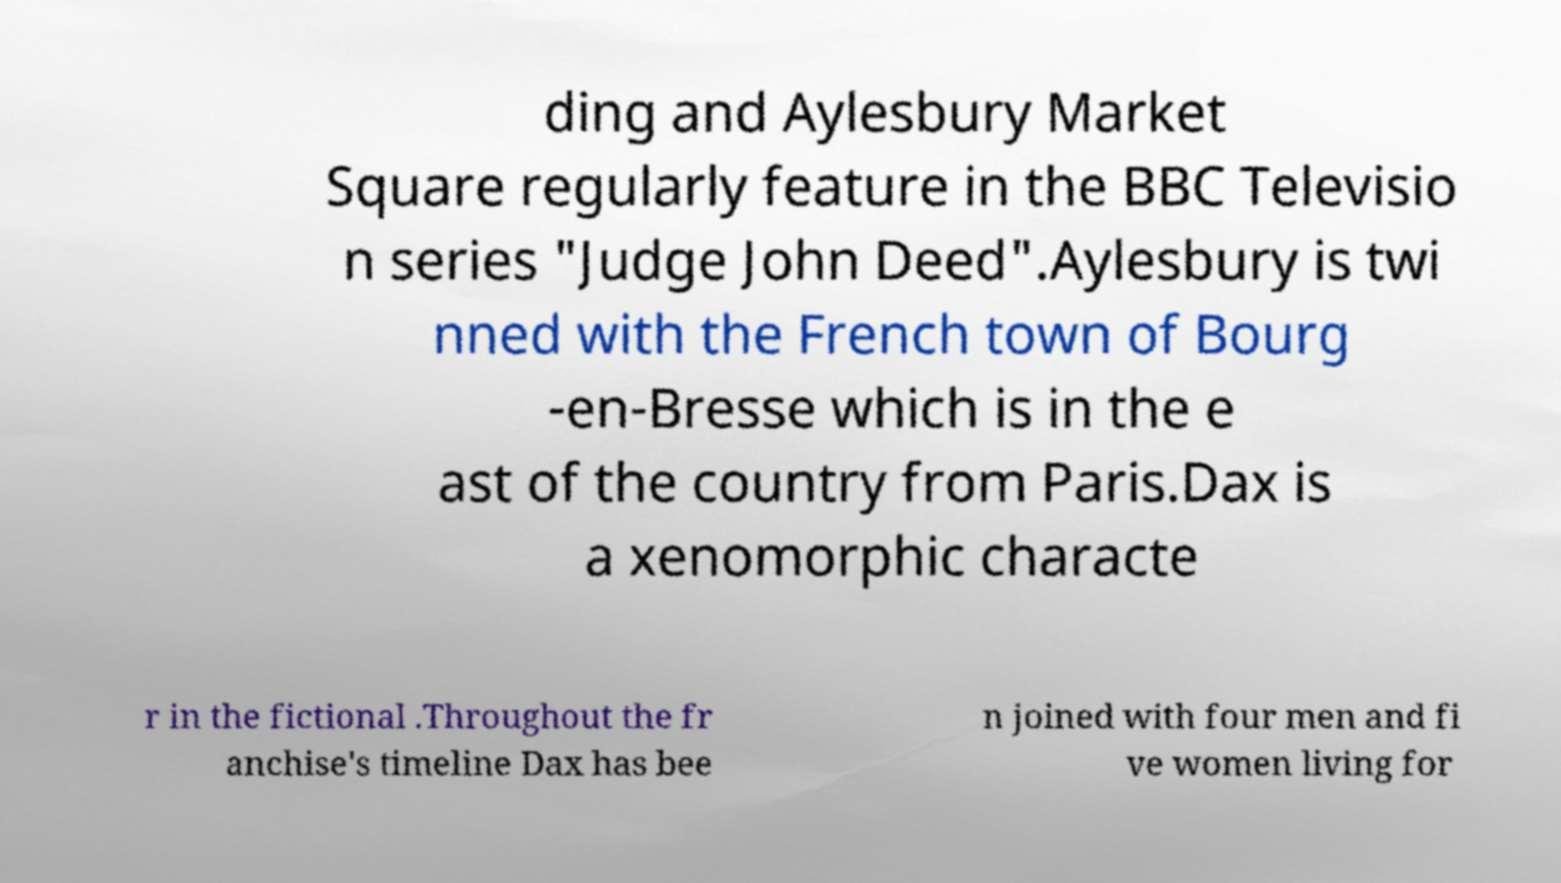Can you read and provide the text displayed in the image?This photo seems to have some interesting text. Can you extract and type it out for me? ding and Aylesbury Market Square regularly feature in the BBC Televisio n series "Judge John Deed".Aylesbury is twi nned with the French town of Bourg -en-Bresse which is in the e ast of the country from Paris.Dax is a xenomorphic characte r in the fictional .Throughout the fr anchise's timeline Dax has bee n joined with four men and fi ve women living for 